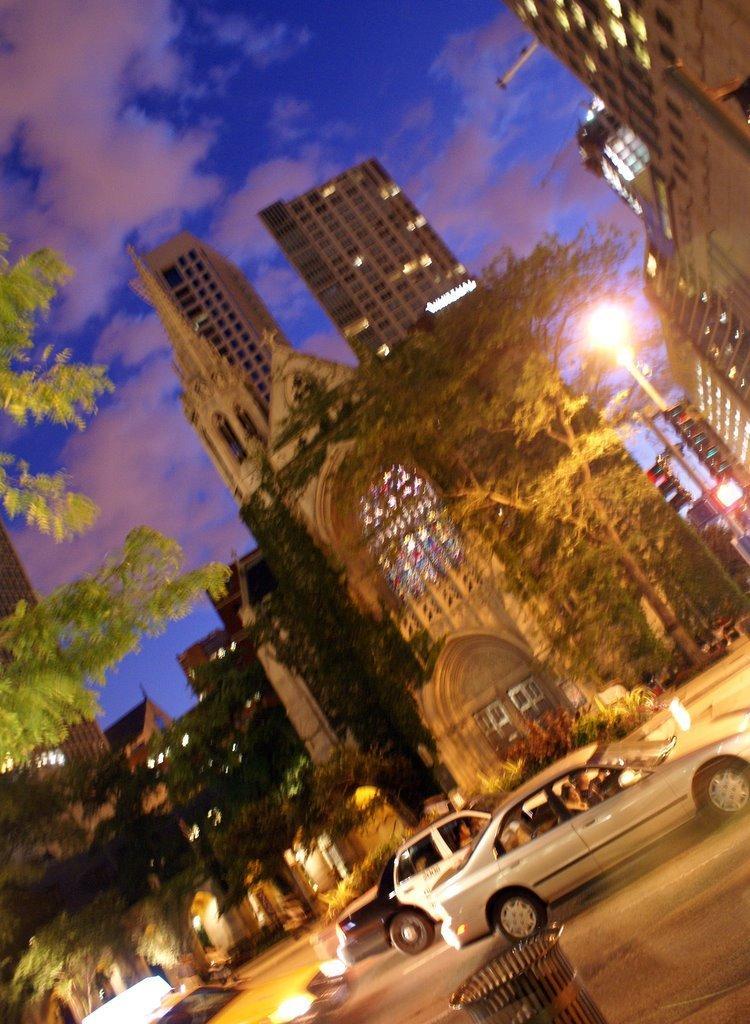How would you summarize this image in a sentence or two? In this image there is a road on that road vehicles are moving, in the background there are light poles, trees, buildings and the sky. 